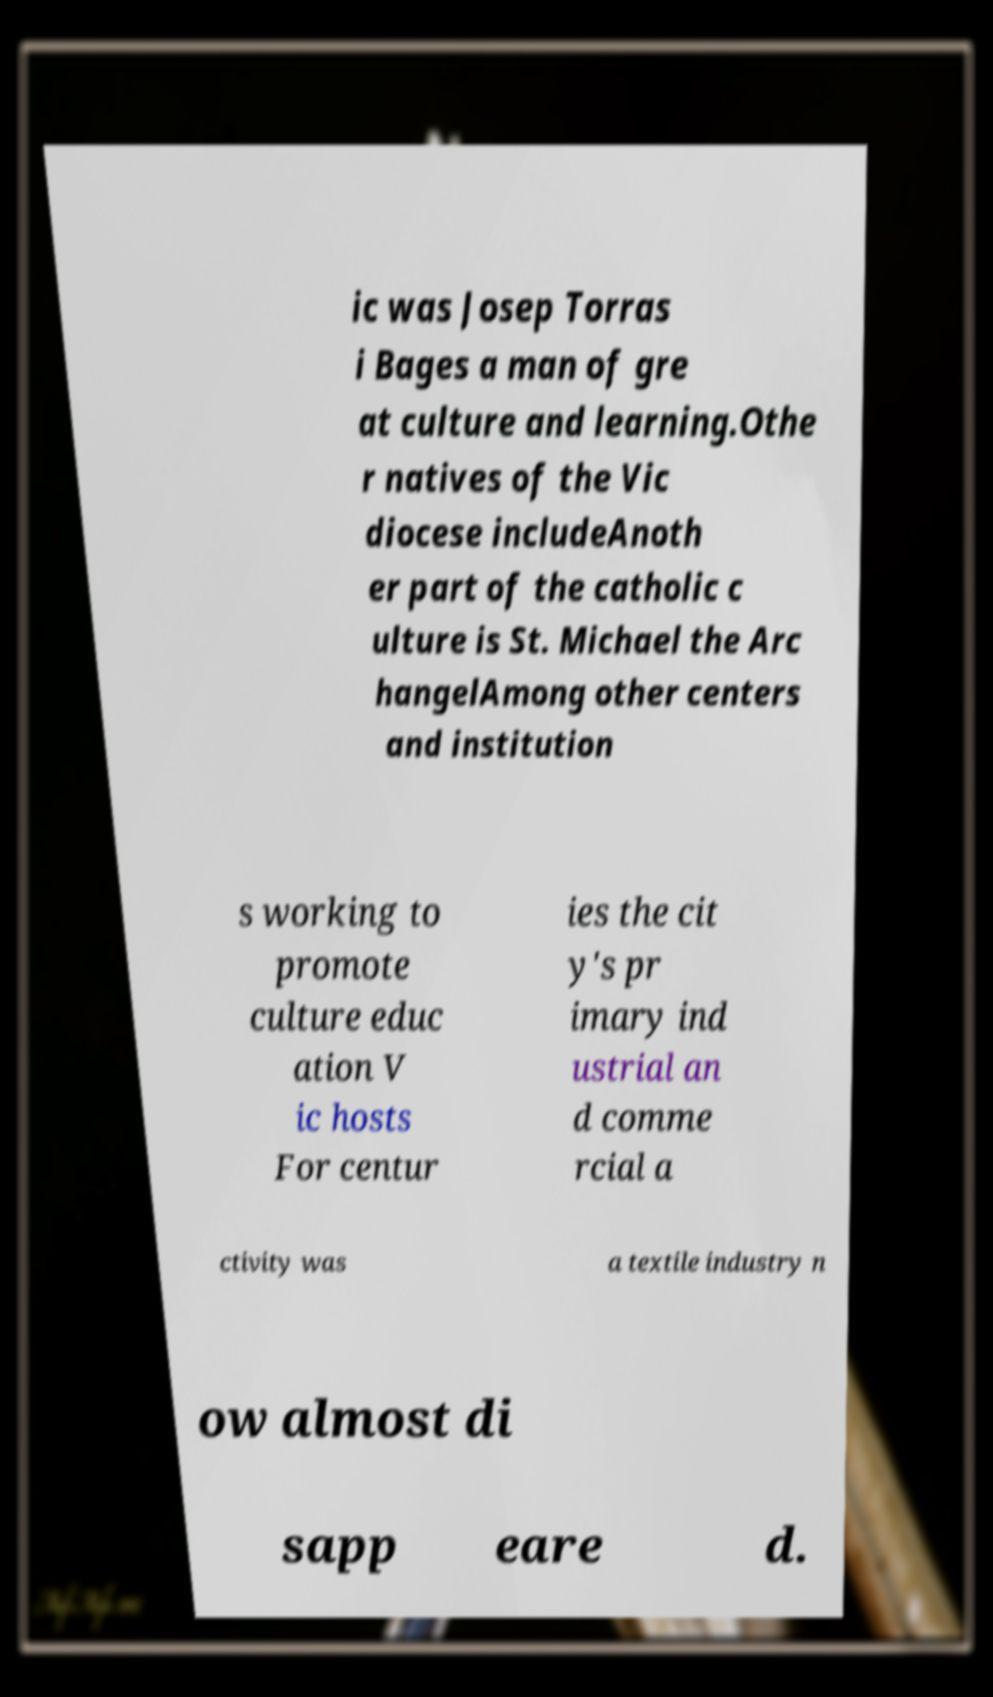There's text embedded in this image that I need extracted. Can you transcribe it verbatim? ic was Josep Torras i Bages a man of gre at culture and learning.Othe r natives of the Vic diocese includeAnoth er part of the catholic c ulture is St. Michael the Arc hangelAmong other centers and institution s working to promote culture educ ation V ic hosts For centur ies the cit y's pr imary ind ustrial an d comme rcial a ctivity was a textile industry n ow almost di sapp eare d. 